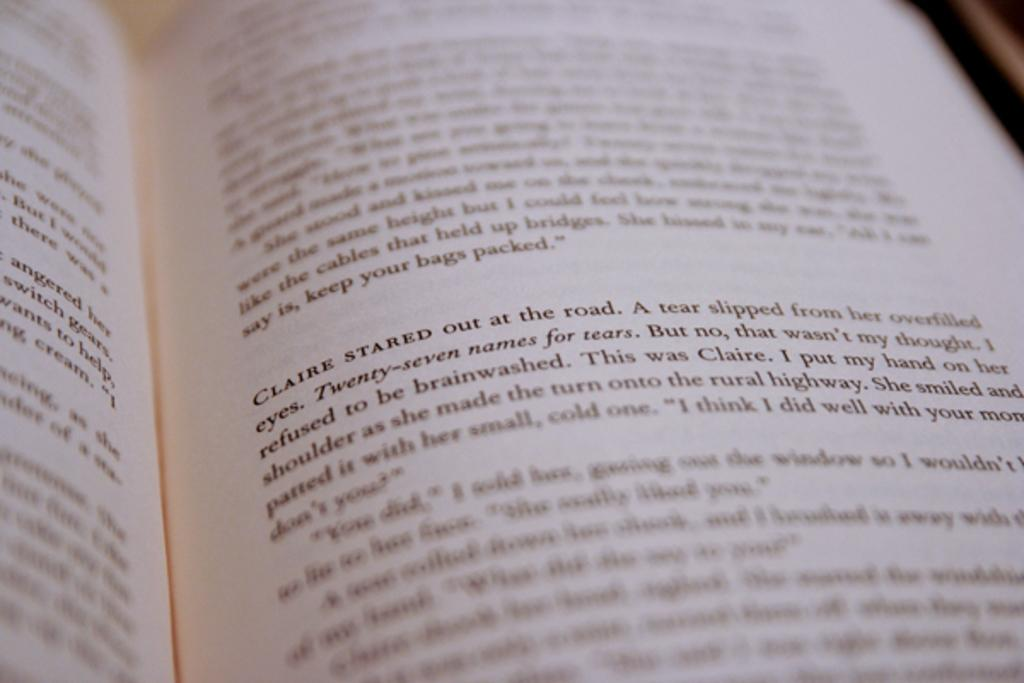Provide a one-sentence caption for the provided image. A book that is focused on the paragraph where Claire stared out at the road. 